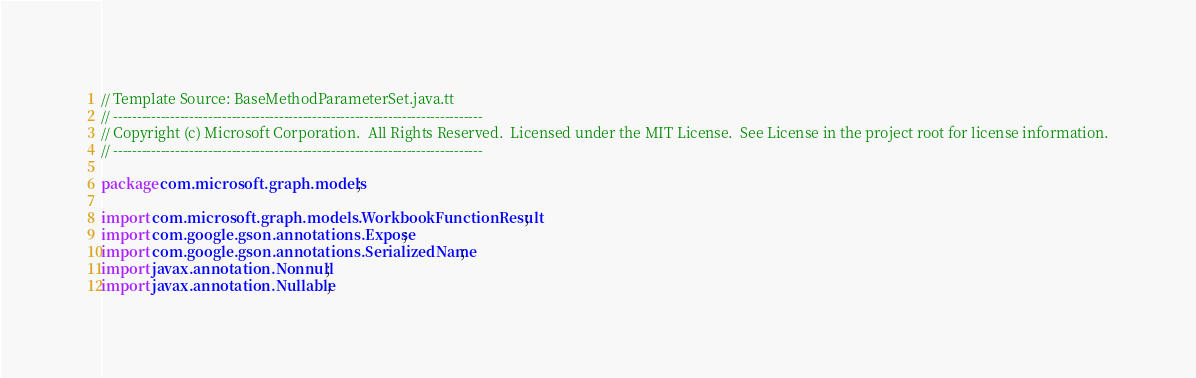Convert code to text. <code><loc_0><loc_0><loc_500><loc_500><_Java_>// Template Source: BaseMethodParameterSet.java.tt
// ------------------------------------------------------------------------------
// Copyright (c) Microsoft Corporation.  All Rights Reserved.  Licensed under the MIT License.  See License in the project root for license information.
// ------------------------------------------------------------------------------

package com.microsoft.graph.models;

import com.microsoft.graph.models.WorkbookFunctionResult;
import com.google.gson.annotations.Expose;
import com.google.gson.annotations.SerializedName;
import javax.annotation.Nonnull;
import javax.annotation.Nullable;</code> 